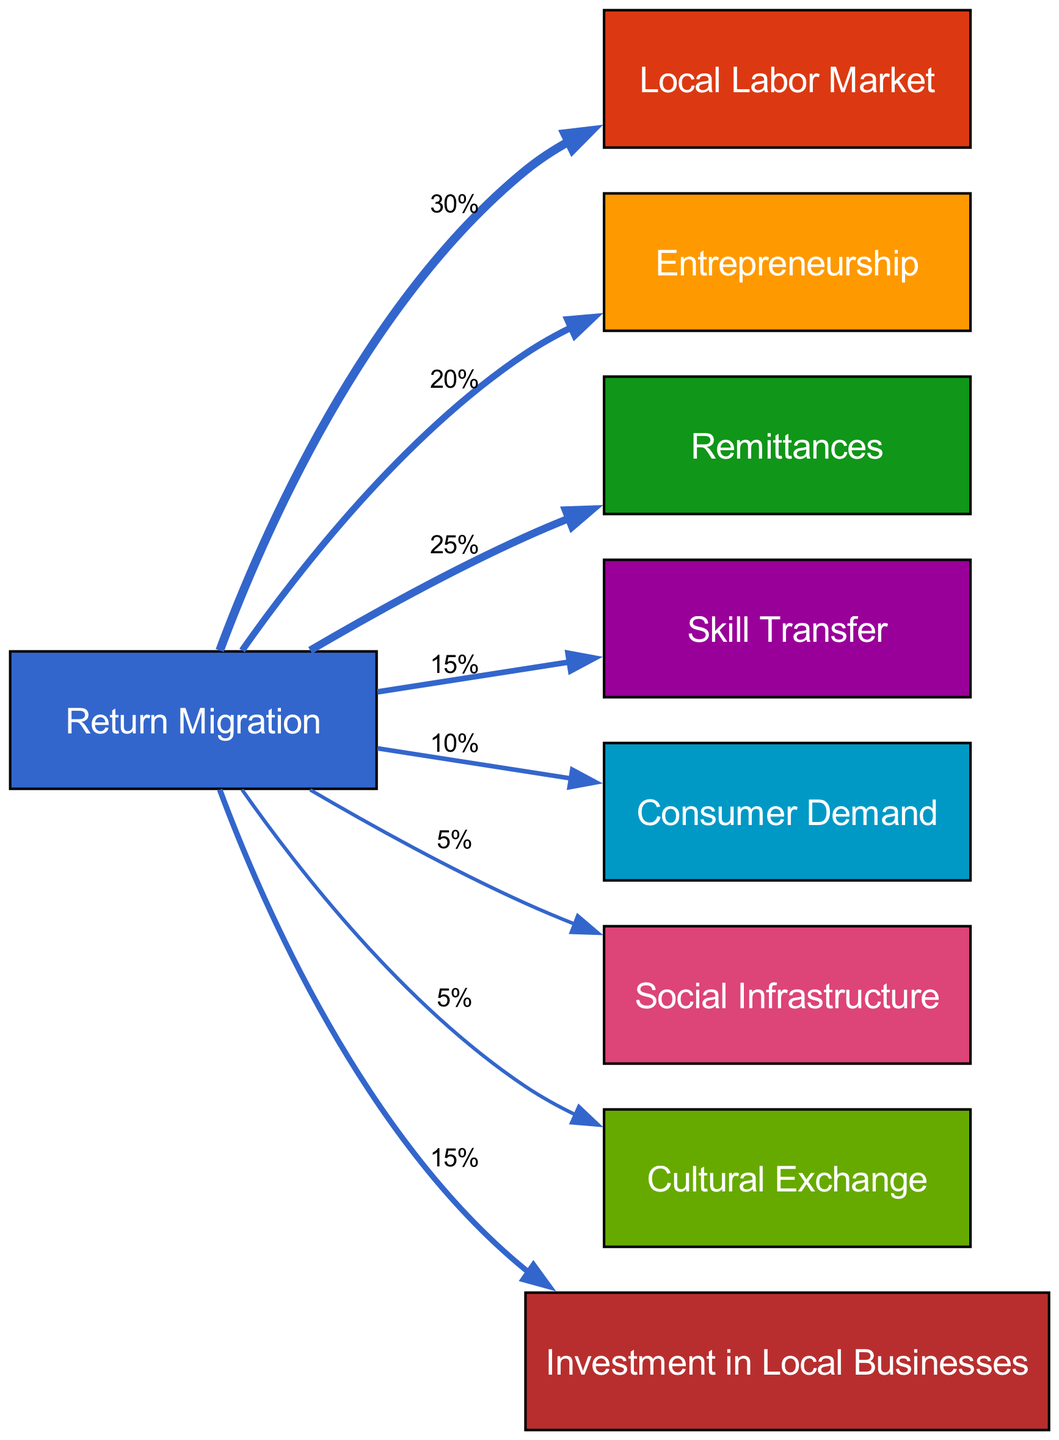What is the percentage value associated with 'Local Labor Market'? From the diagram, we see that the flow connecting 'Return Migration' to 'Local Labor Market' has a value that signifies the percentage impact. Looking at the corresponding label on the edge, the value is 30%.
Answer: 30% How many nodes are present in the diagram? By counting the distinct entries within the 'nodes' section of the diagram, we find there are a total of 9 unique nodes listed.
Answer: 9 Which outcome has the least impact from return migration? Analyzing the edges emanating from 'Return Migration', we identify the flows and their associated values. The flows leading to 'Social Infrastructure' and 'Cultural Exchange' each have a value of 5%, which are the smallest.
Answer: Social Infrastructure What is the total percentage of 'Remittances' and 'Investment in Local Businesses'? We examine the values for 'Remittances' at 25% and 'Investment in Local Businesses' at 15%. Adding these two values, we find that 25 + 15 equals 40%.
Answer: 40% Which node receives a greater impact: 'Skill Transfer' or 'Consumer Demand'? Looking at the values in the diagram, 'Skill Transfer' is associated with a value of 15% and 'Consumer Demand' is associated with a value of 10%. Since 15% is greater than 10%, we conclude that 'Skill Transfer' receives a greater impact.
Answer: Skill Transfer What is the sum of all the values leading from 'Return Migration'? To find the total impact from 'Return Migration', we sum all the percentage values of its connections: 30% + 20% + 25% + 15% + 10% + 5% + 5% + 15% = 125%.
Answer: 125% How does 'Entrepreneurship' compare in impact to 'Skill Transfer'? The value associated with 'Entrepreneurship' is 20%, while 'Skill Transfer' has a value of 15%. Thus, 'Entrepreneurship' has a higher impact compared to 'Skill Transfer' since 20% is greater than 15%.
Answer: Entrepreneurship Which two outcomes share the same impact value and what is that value? By reviewing the impact values, we identify both 'Social Infrastructure' and 'Cultural Exchange' that are both associated with a value of 5%. Thus, they share the same impact value of 5%.
Answer: 5% 